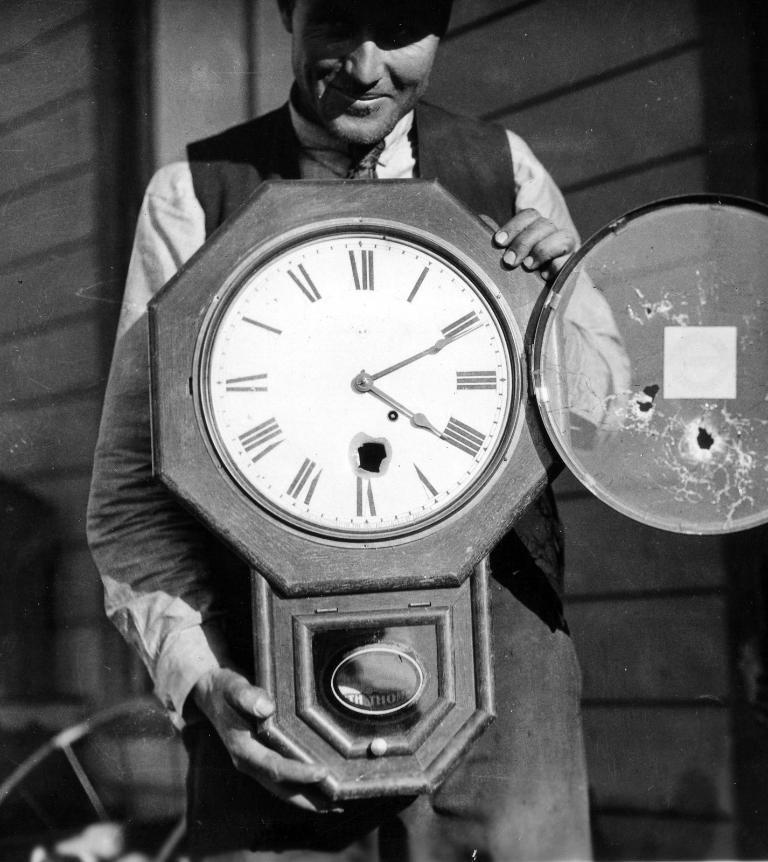<image>
Describe the image concisely. A man is holding a clock that shows the time as 4:11. 